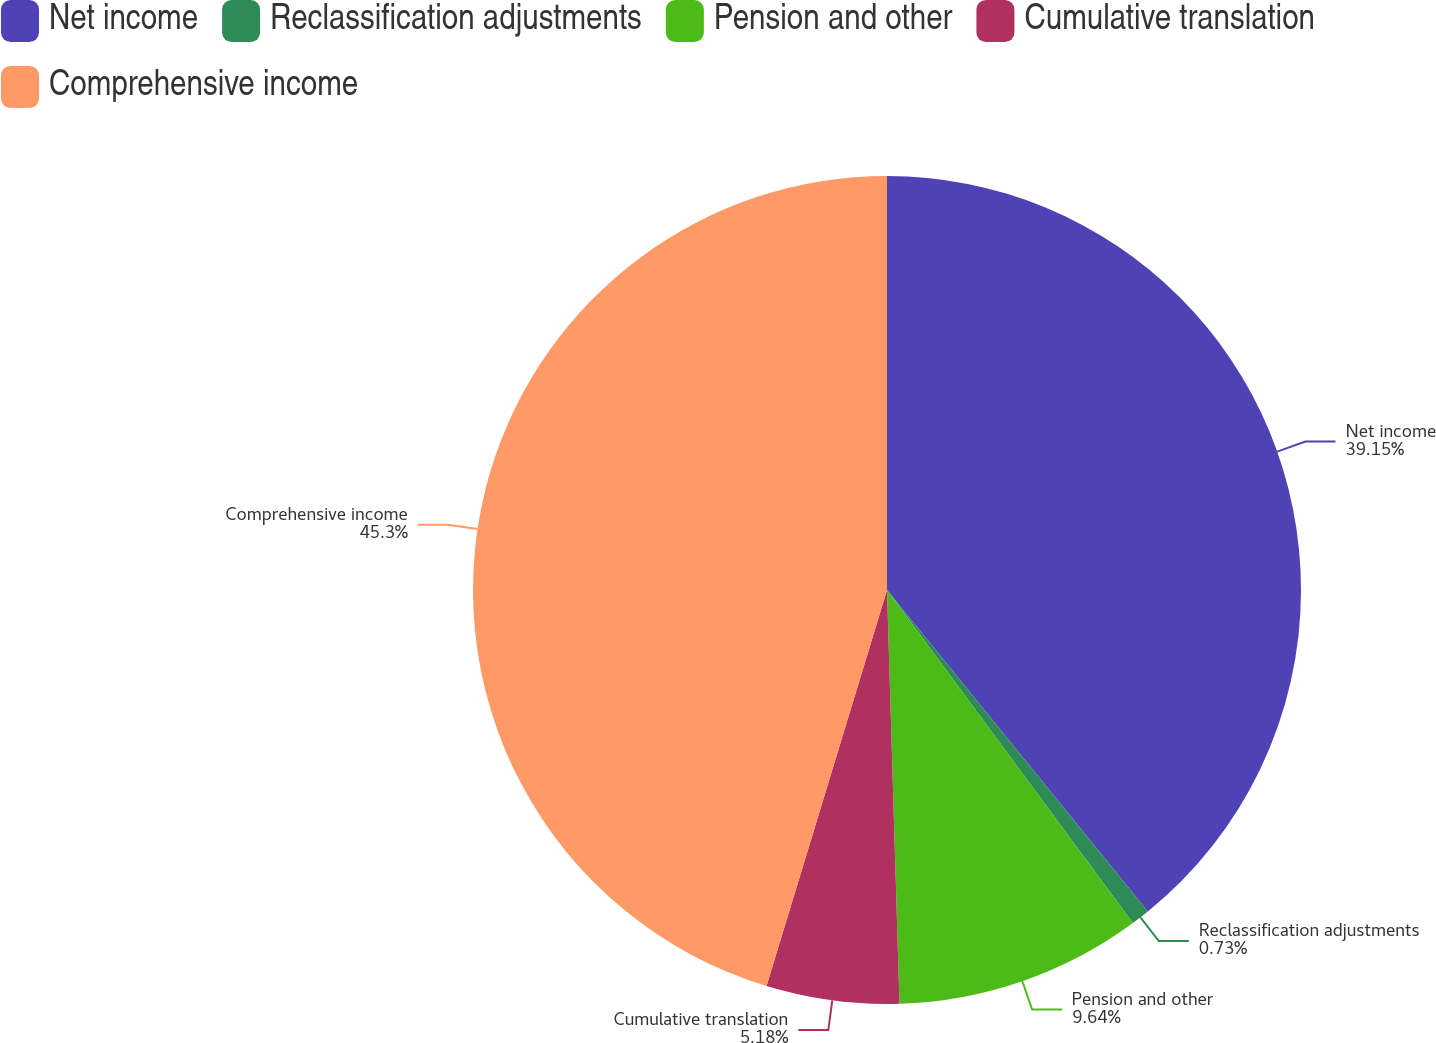Convert chart. <chart><loc_0><loc_0><loc_500><loc_500><pie_chart><fcel>Net income<fcel>Reclassification adjustments<fcel>Pension and other<fcel>Cumulative translation<fcel>Comprehensive income<nl><fcel>39.15%<fcel>0.73%<fcel>9.64%<fcel>5.18%<fcel>45.3%<nl></chart> 